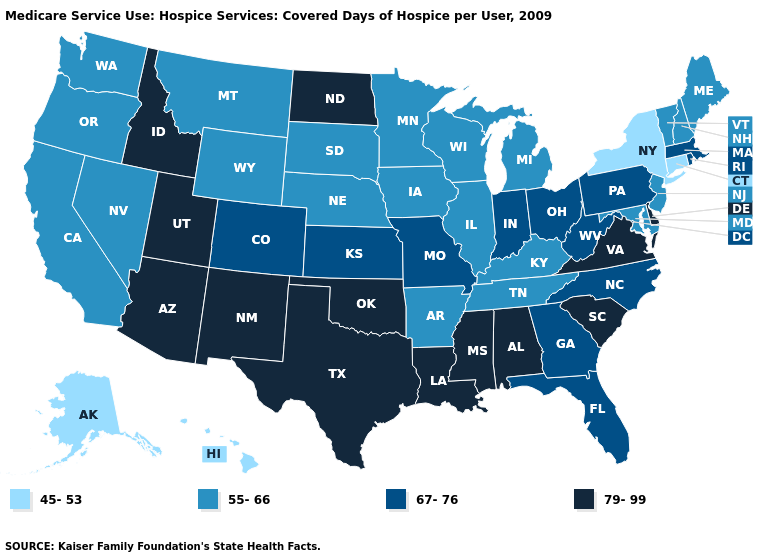Name the states that have a value in the range 45-53?
Answer briefly. Alaska, Connecticut, Hawaii, New York. Which states have the highest value in the USA?
Answer briefly. Alabama, Arizona, Delaware, Idaho, Louisiana, Mississippi, New Mexico, North Dakota, Oklahoma, South Carolina, Texas, Utah, Virginia. Name the states that have a value in the range 67-76?
Be succinct. Colorado, Florida, Georgia, Indiana, Kansas, Massachusetts, Missouri, North Carolina, Ohio, Pennsylvania, Rhode Island, West Virginia. What is the highest value in states that border Arkansas?
Answer briefly. 79-99. Which states have the lowest value in the South?
Answer briefly. Arkansas, Kentucky, Maryland, Tennessee. What is the highest value in the South ?
Give a very brief answer. 79-99. What is the highest value in the USA?
Give a very brief answer. 79-99. Name the states that have a value in the range 67-76?
Concise answer only. Colorado, Florida, Georgia, Indiana, Kansas, Massachusetts, Missouri, North Carolina, Ohio, Pennsylvania, Rhode Island, West Virginia. Does North Dakota have the highest value in the MidWest?
Be succinct. Yes. How many symbols are there in the legend?
Be succinct. 4. What is the highest value in the USA?
Be succinct. 79-99. What is the value of Pennsylvania?
Be succinct. 67-76. Name the states that have a value in the range 67-76?
Quick response, please. Colorado, Florida, Georgia, Indiana, Kansas, Massachusetts, Missouri, North Carolina, Ohio, Pennsylvania, Rhode Island, West Virginia. Name the states that have a value in the range 55-66?
Be succinct. Arkansas, California, Illinois, Iowa, Kentucky, Maine, Maryland, Michigan, Minnesota, Montana, Nebraska, Nevada, New Hampshire, New Jersey, Oregon, South Dakota, Tennessee, Vermont, Washington, Wisconsin, Wyoming. Among the states that border Georgia , does Tennessee have the lowest value?
Write a very short answer. Yes. 